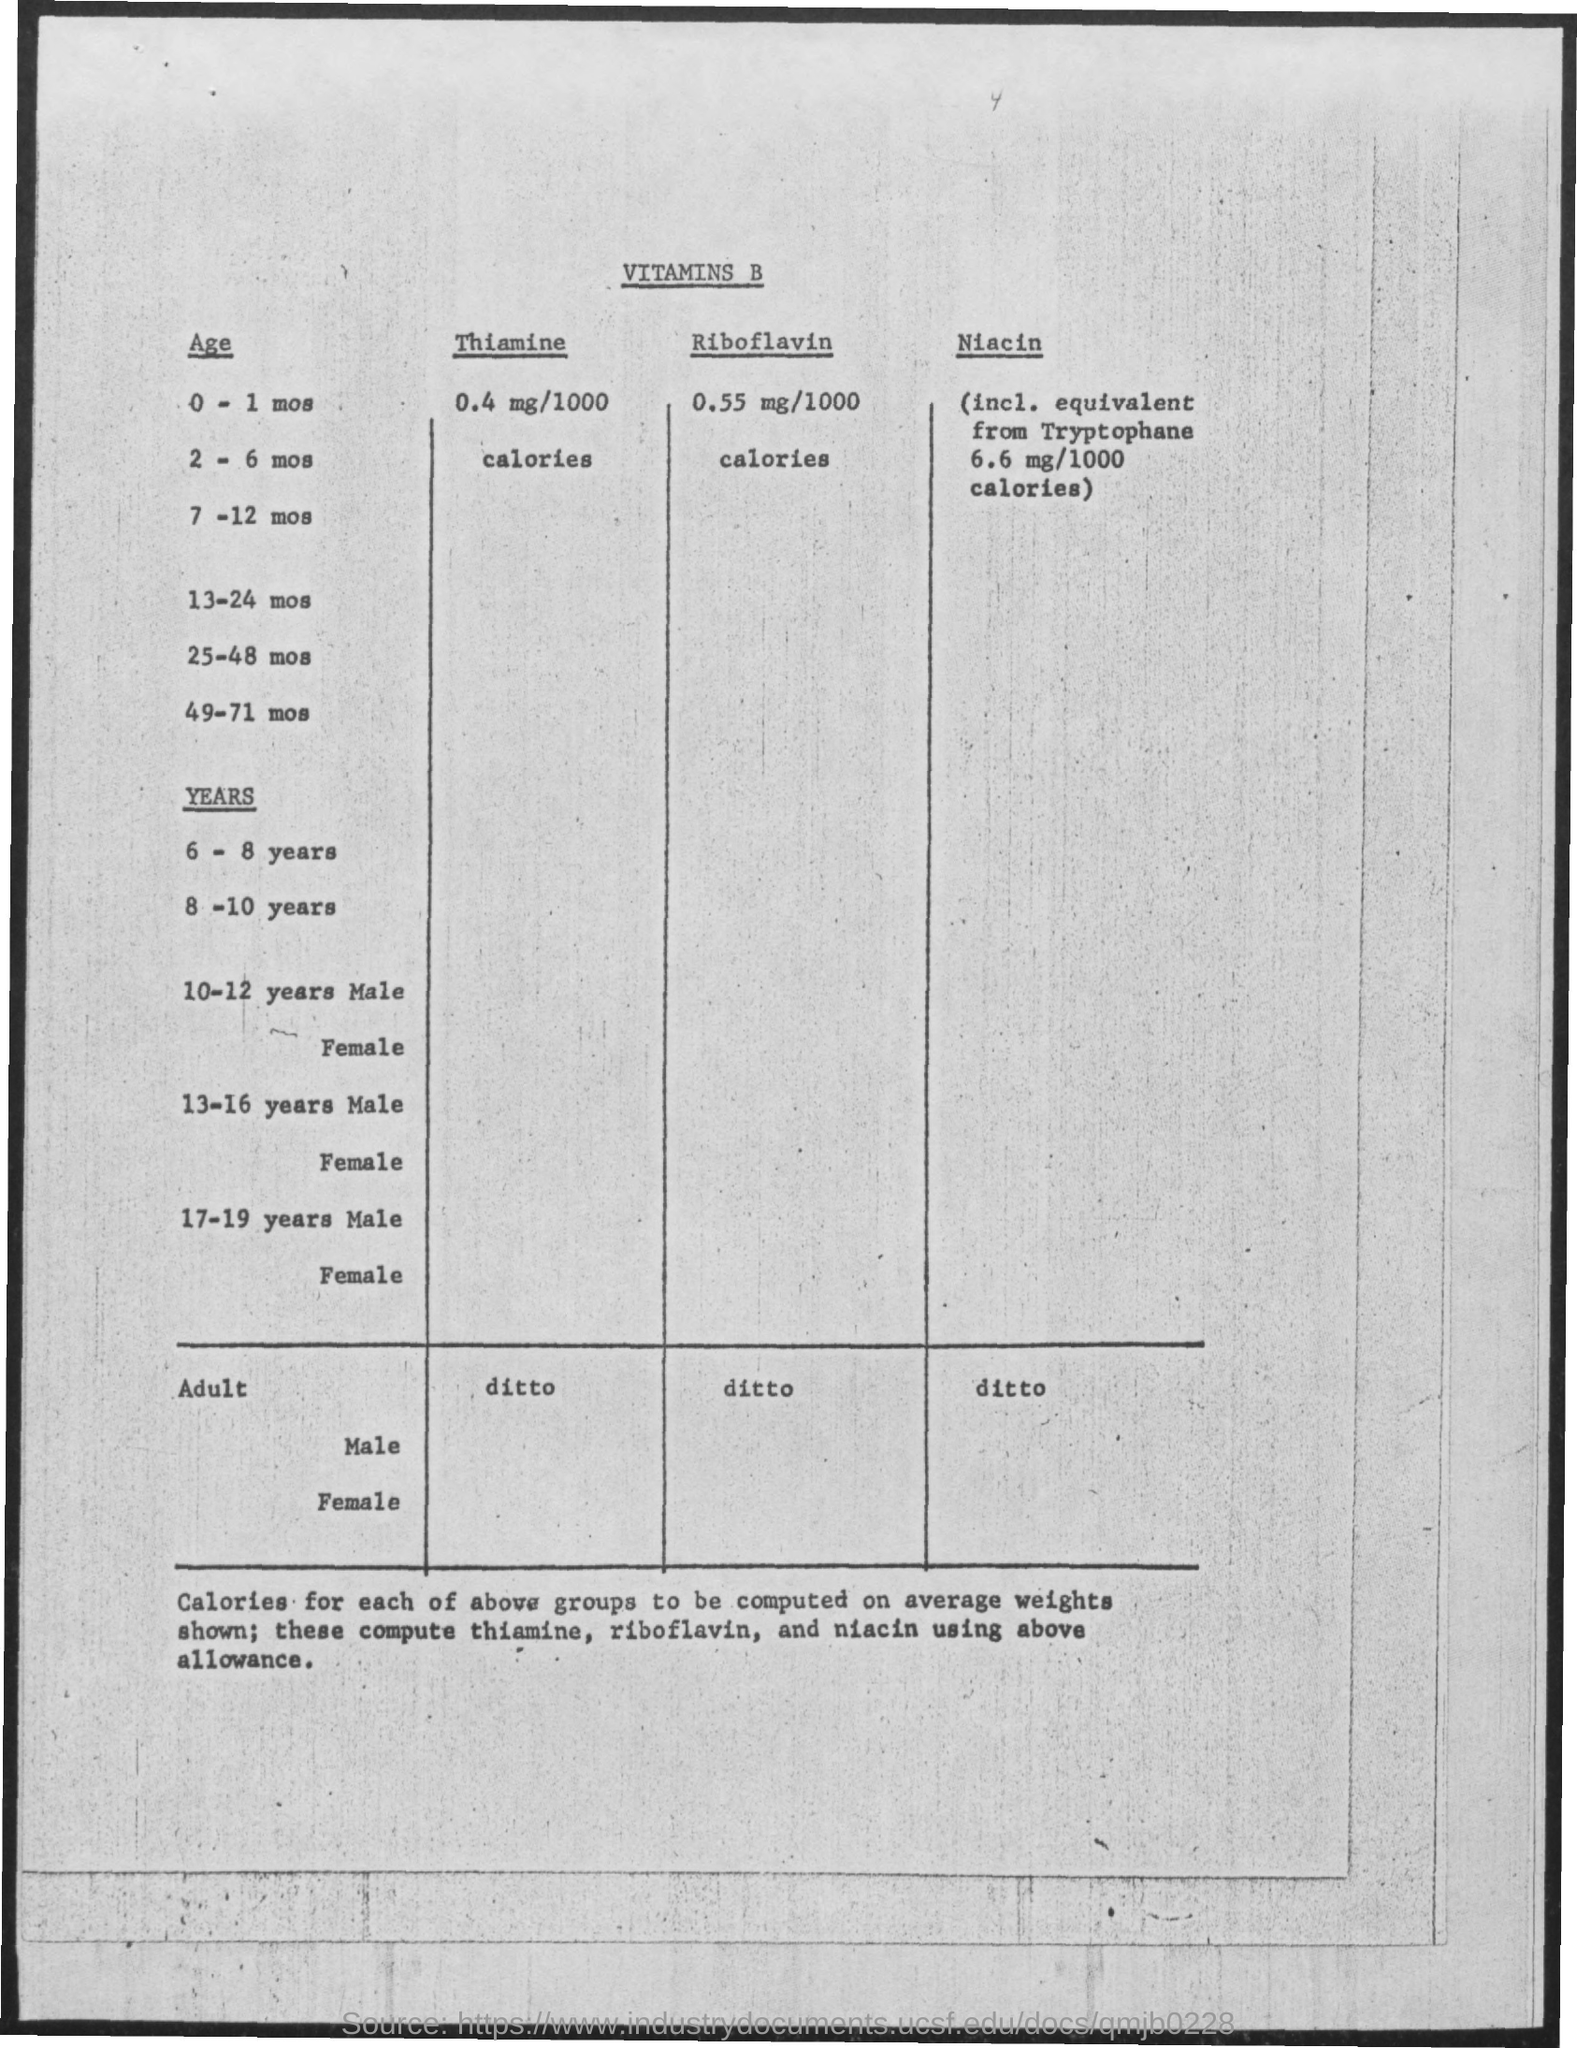Point out several critical features in this image. The first title in the document is 'Vitamins B...' The second column is named 'thiamine'. 